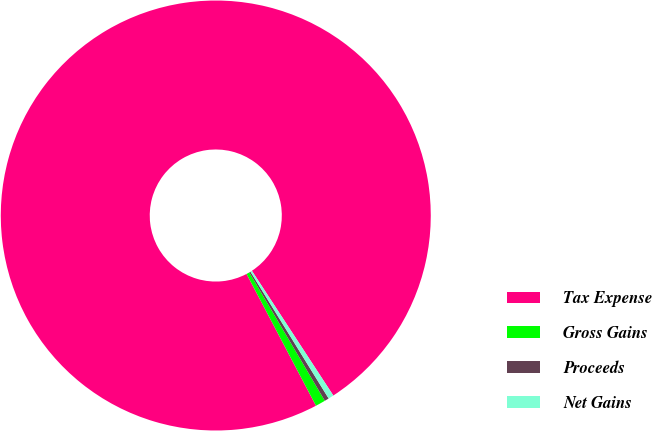Convert chart to OTSL. <chart><loc_0><loc_0><loc_500><loc_500><pie_chart><fcel>Tax Expense<fcel>Gross Gains<fcel>Proceeds<fcel>Net Gains<nl><fcel>98.51%<fcel>0.75%<fcel>0.33%<fcel>0.41%<nl></chart> 